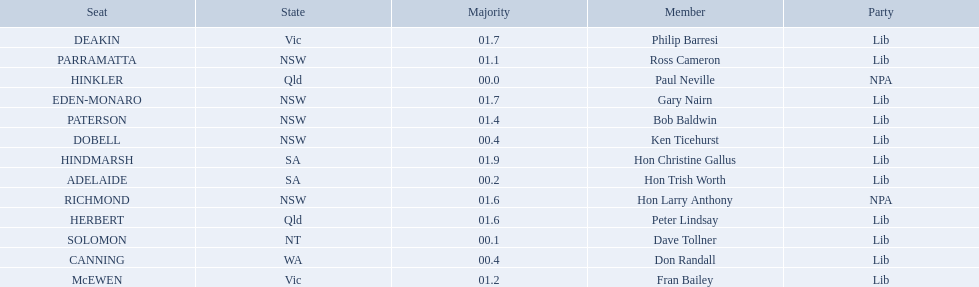Which seats are represented in the electoral system of australia? HINKLER, SOLOMON, ADELAIDE, CANNING, DOBELL, PARRAMATTA, McEWEN, PATERSON, HERBERT, RICHMOND, DEAKIN, EDEN-MONARO, HINDMARSH. What were their majority numbers of both hindmarsh and hinkler? HINKLER, HINDMARSH. Of those two seats, what is the difference in voting majority? 01.9. Who are all the lib party members? Dave Tollner, Hon Trish Worth, Don Randall, Ken Ticehurst, Ross Cameron, Fran Bailey, Bob Baldwin, Peter Lindsay, Philip Barresi, Gary Nairn, Hon Christine Gallus. What lib party members are in sa? Hon Trish Worth, Hon Christine Gallus. What is the highest difference in majority between members in sa? 01.9. 